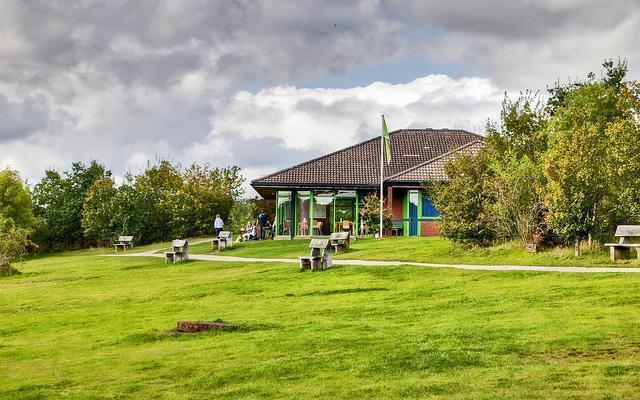What flowers might grow wild in this environment?
Pick the right solution, then justify: 'Answer: answer
Rationale: rationale.'
Options: Roses, dhalias, dandelions, foxglove. Answer: dandelions.
Rationale: They are found in a lot of grassy areas 